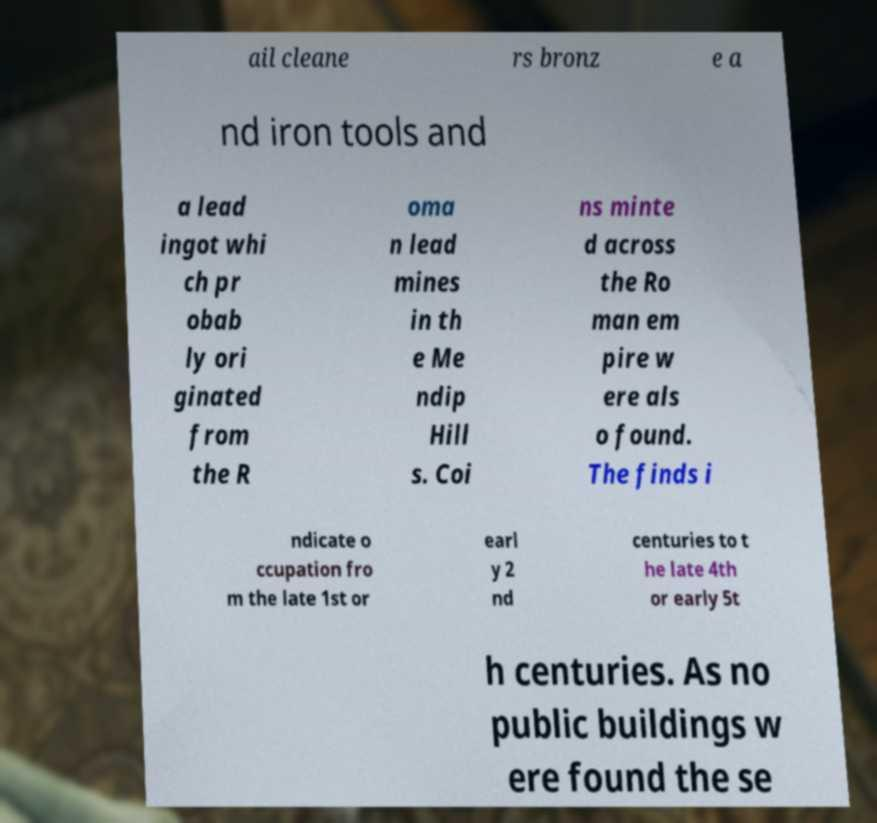Please identify and transcribe the text found in this image. ail cleane rs bronz e a nd iron tools and a lead ingot whi ch pr obab ly ori ginated from the R oma n lead mines in th e Me ndip Hill s. Coi ns minte d across the Ro man em pire w ere als o found. The finds i ndicate o ccupation fro m the late 1st or earl y 2 nd centuries to t he late 4th or early 5t h centuries. As no public buildings w ere found the se 